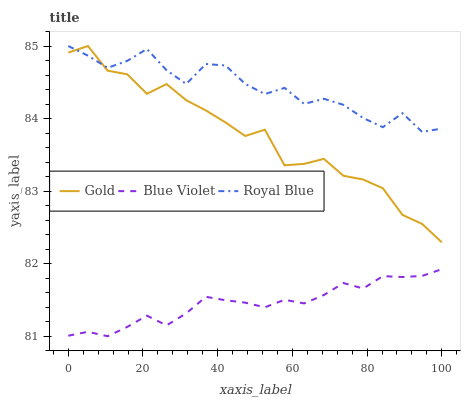Does Blue Violet have the minimum area under the curve?
Answer yes or no. Yes. Does Royal Blue have the maximum area under the curve?
Answer yes or no. Yes. Does Gold have the minimum area under the curve?
Answer yes or no. No. Does Gold have the maximum area under the curve?
Answer yes or no. No. Is Blue Violet the smoothest?
Answer yes or no. Yes. Is Gold the roughest?
Answer yes or no. Yes. Is Gold the smoothest?
Answer yes or no. No. Is Blue Violet the roughest?
Answer yes or no. No. Does Blue Violet have the lowest value?
Answer yes or no. Yes. Does Gold have the lowest value?
Answer yes or no. No. Does Gold have the highest value?
Answer yes or no. Yes. Does Blue Violet have the highest value?
Answer yes or no. No. Is Blue Violet less than Gold?
Answer yes or no. Yes. Is Gold greater than Blue Violet?
Answer yes or no. Yes. Does Royal Blue intersect Gold?
Answer yes or no. Yes. Is Royal Blue less than Gold?
Answer yes or no. No. Is Royal Blue greater than Gold?
Answer yes or no. No. Does Blue Violet intersect Gold?
Answer yes or no. No. 